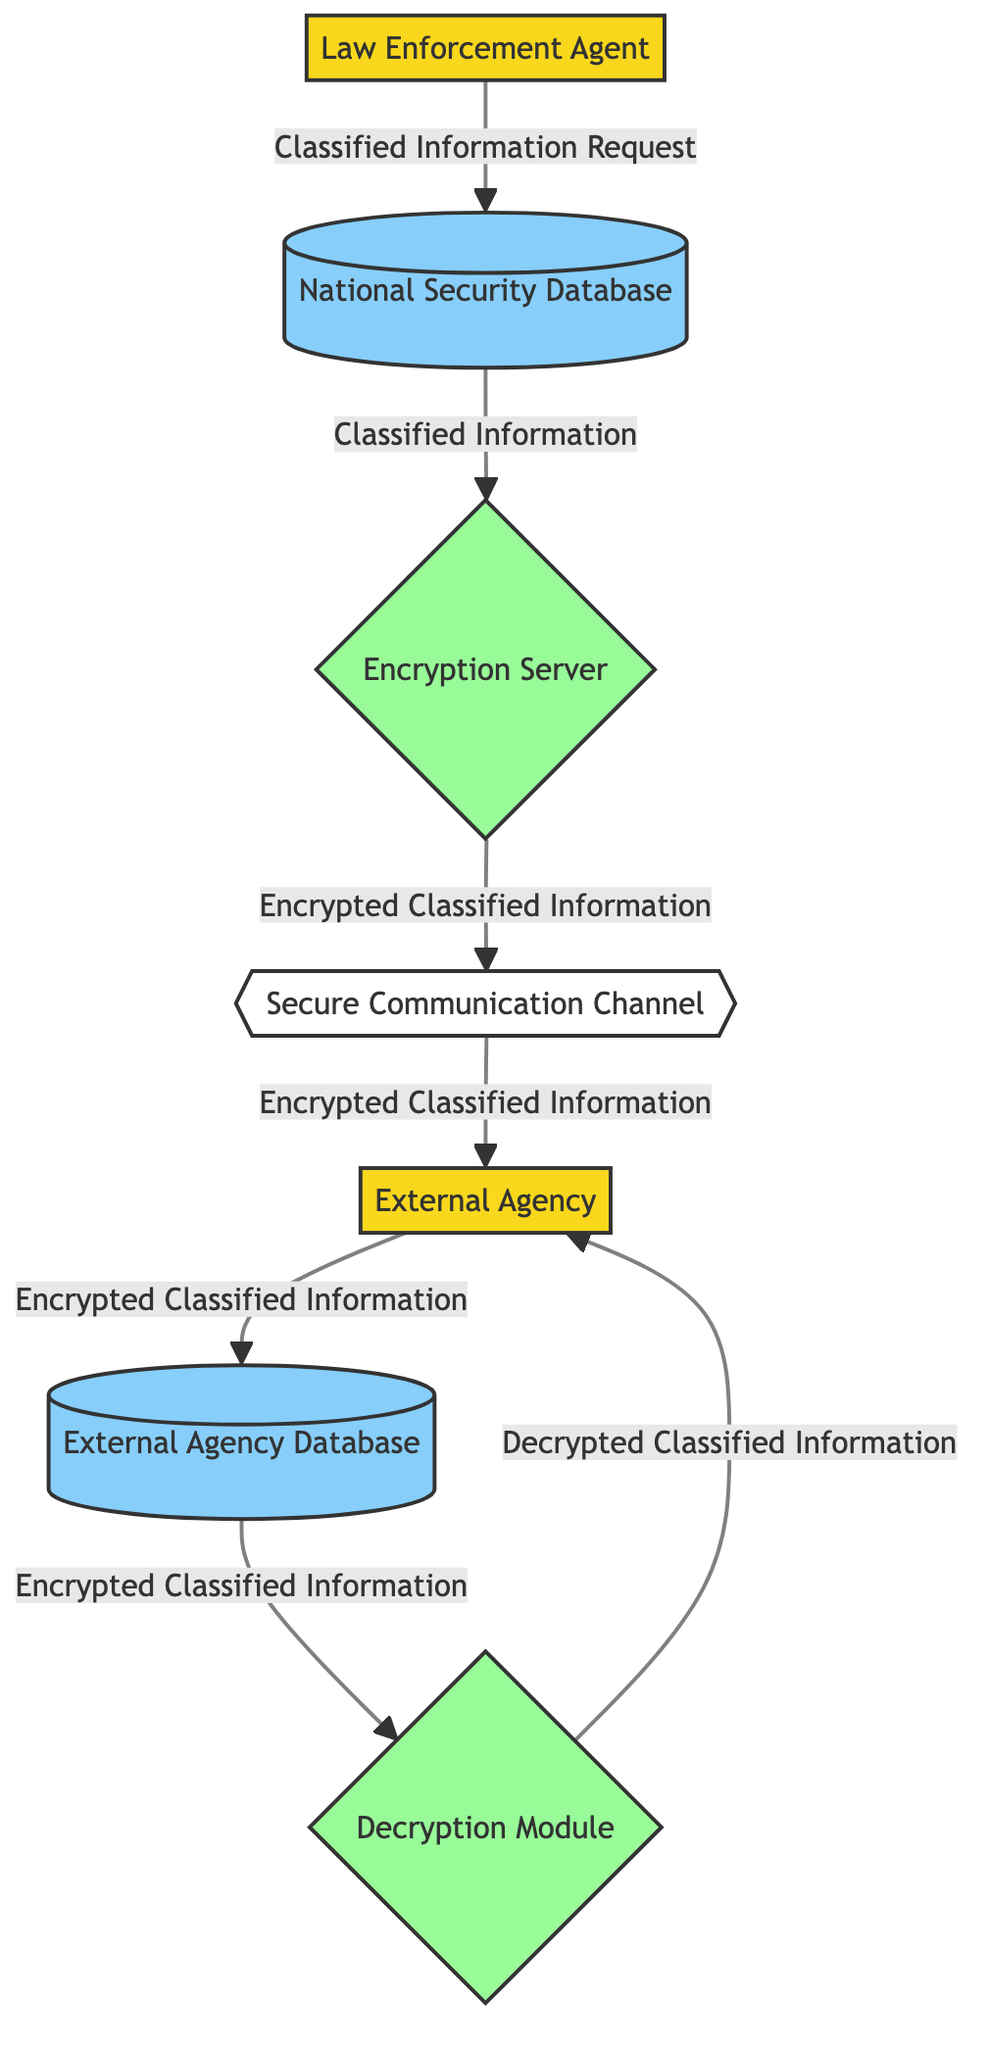What is the source for the flow labeled "Classified Information"? The flow labeled "Classified Information" starts from the National Security Database, which is the source entity in this flow.
Answer: National Security Database How many external entities are present in the diagram? There are two external entities in the diagram: the Law Enforcement Agent and the External Agency. By counting them, we can see there are indeed two.
Answer: 2 What process is responsible for encrypting classified information? The Encryption Server is responsible for encrypting classified information as it is the process that takes the classified information from the data store and performs encryption.
Answer: Encryption Server What data flow connects the External Agency to its database? The data flow labeled "Encrypted Classified Information" connects the External Agency to the External Agency Database, as it is shown directly flowing from the External Agency to its corresponding database.
Answer: Encrypted Classified Information What is the final output received by the External Agency from the Decryption Module? The final output received by the External Agency from the Decryption Module is the Decrypted Classified Information. It is the data that flows from the Decryption Module back to the External Agency.
Answer: Decrypted Classified Information Which entity is involved in both the request and the response processes? The Law Enforcement Agent is involved in both the request process, where they send a "Classified Information Request" and in the overall communication feedback loop to an external agency.
Answer: Law Enforcement Agent What type of process is the Secure Communication Channel? The Secure Communication Channel is categorized as a data flow, facilitating the transfer of encrypted classified information between the Encryption Server and the External Agency.
Answer: Data Flow How does the External Agency receive encrypted information? The External Agency receives the encrypted information through the Secure Communication Channel, which transmits this data after it has been encrypted by the Encryption Server.
Answer: Secure Communication Channel 